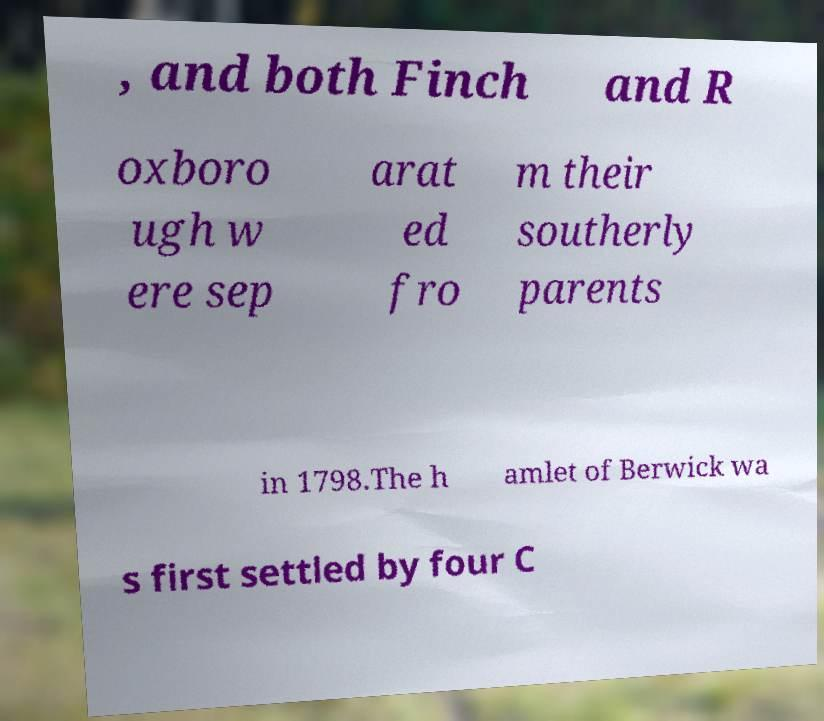I need the written content from this picture converted into text. Can you do that? , and both Finch and R oxboro ugh w ere sep arat ed fro m their southerly parents in 1798.The h amlet of Berwick wa s first settled by four C 